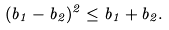Convert formula to latex. <formula><loc_0><loc_0><loc_500><loc_500>( b _ { 1 } - b _ { 2 } ) ^ { 2 } \leq b _ { 1 } + b _ { 2 } .</formula> 